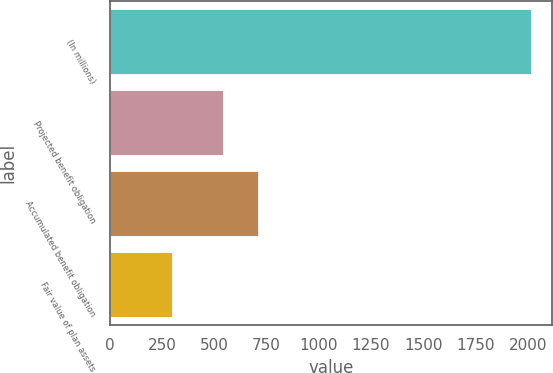Convert chart to OTSL. <chart><loc_0><loc_0><loc_500><loc_500><bar_chart><fcel>(In millions)<fcel>Projected benefit obligation<fcel>Accumulated benefit obligation<fcel>Fair value of plan assets<nl><fcel>2014<fcel>540<fcel>711.4<fcel>300<nl></chart> 